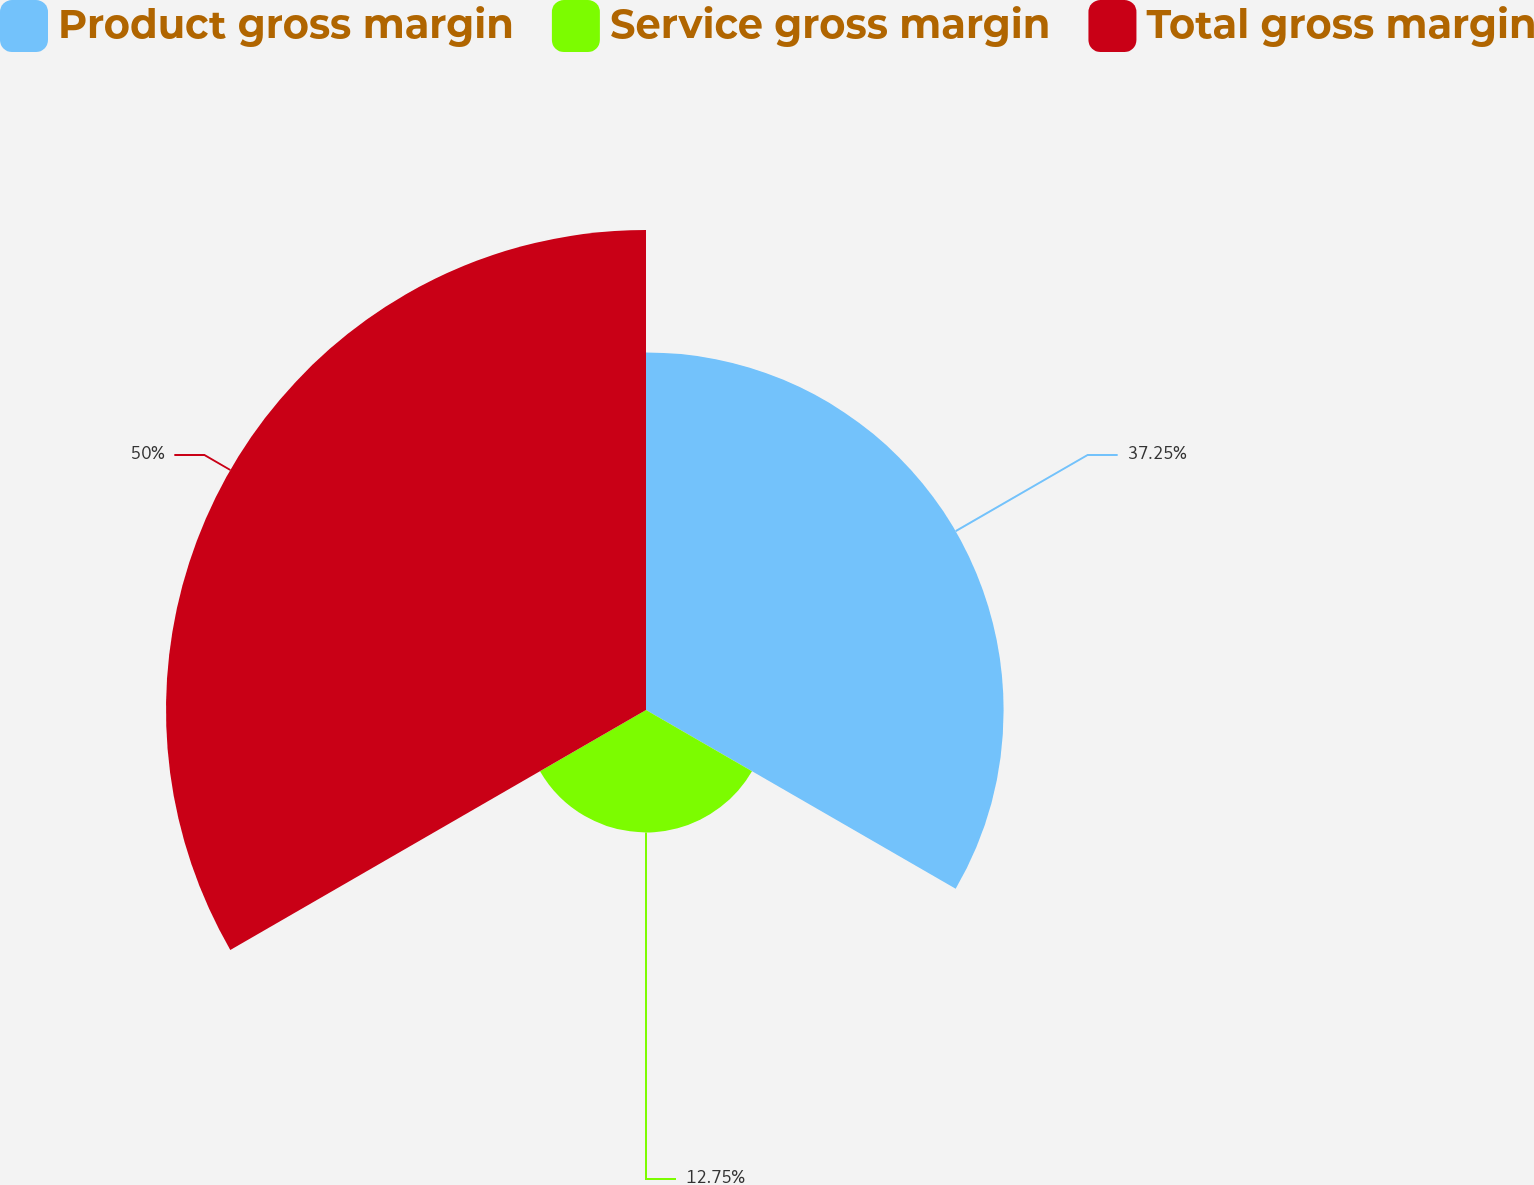<chart> <loc_0><loc_0><loc_500><loc_500><pie_chart><fcel>Product gross margin<fcel>Service gross margin<fcel>Total gross margin<nl><fcel>37.25%<fcel>12.75%<fcel>50.0%<nl></chart> 